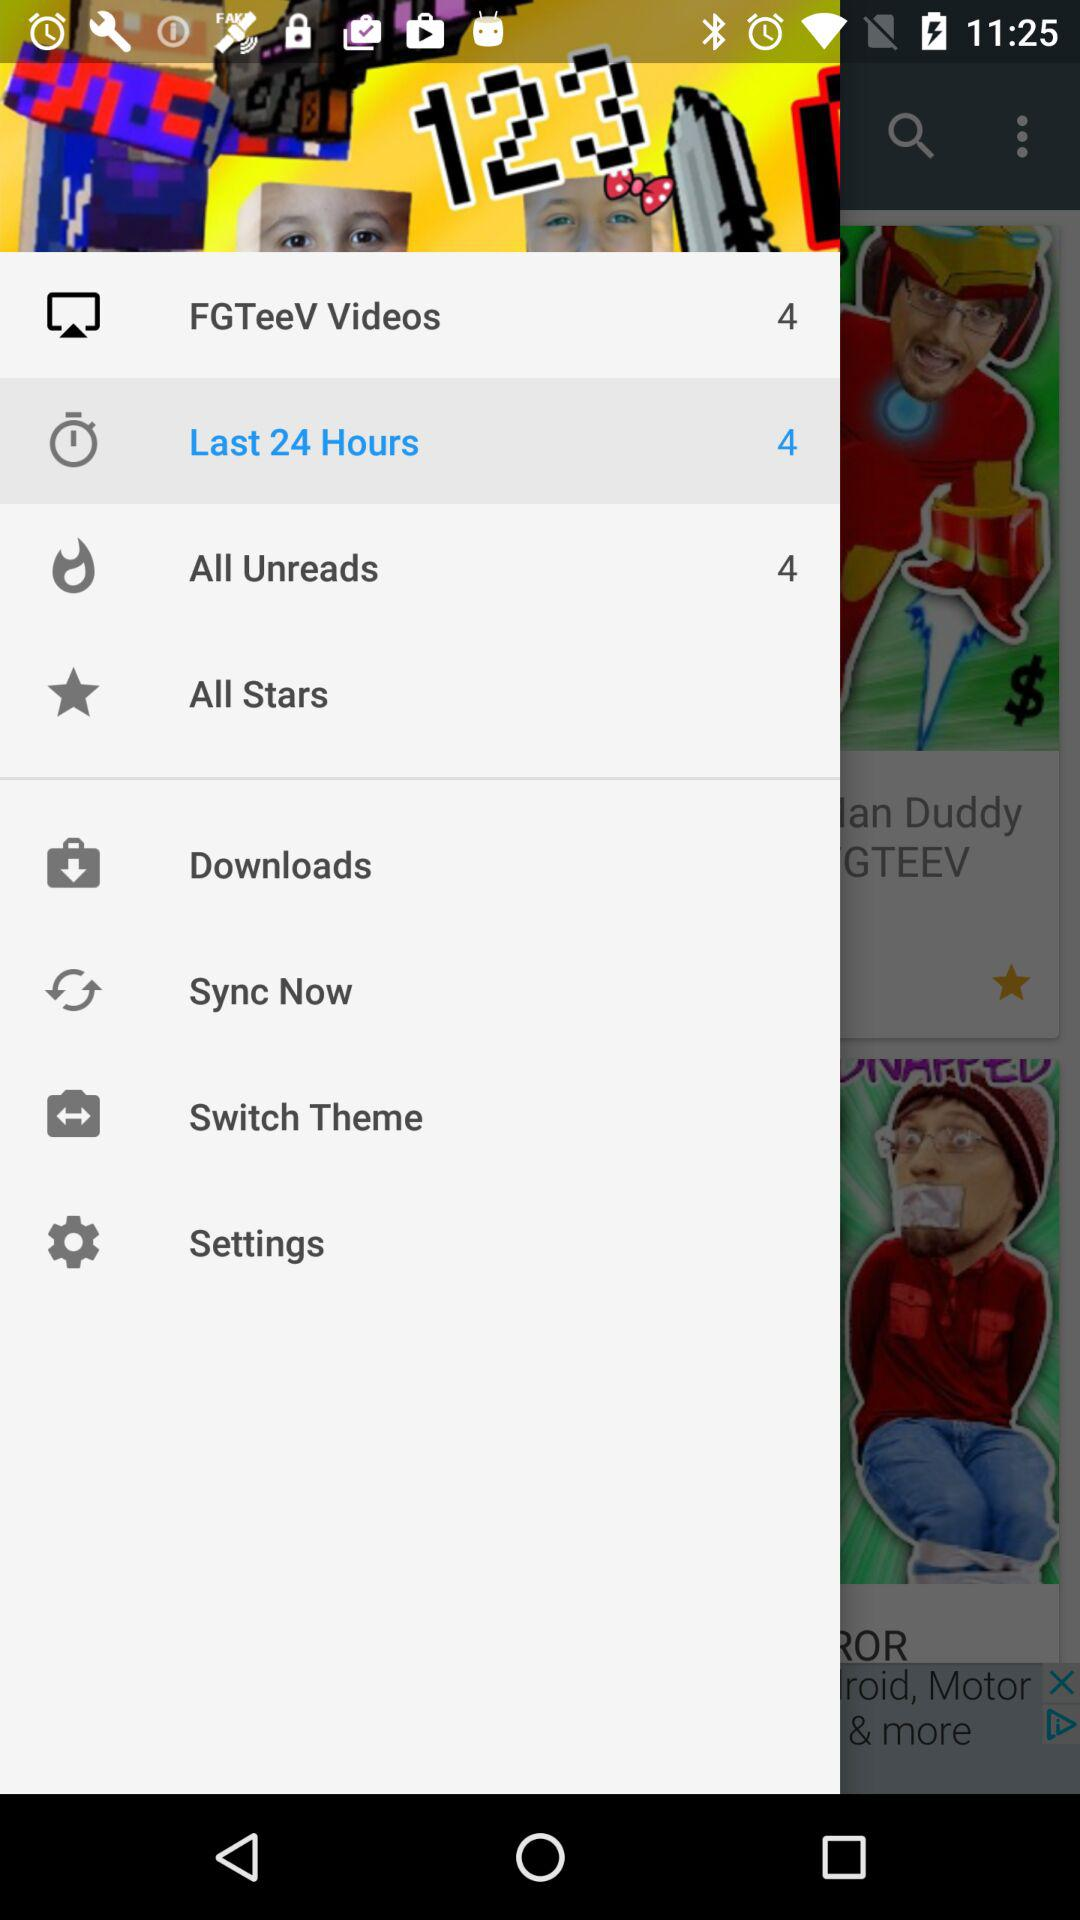What is the selected option? The selected option is "Last 24 Hours". 